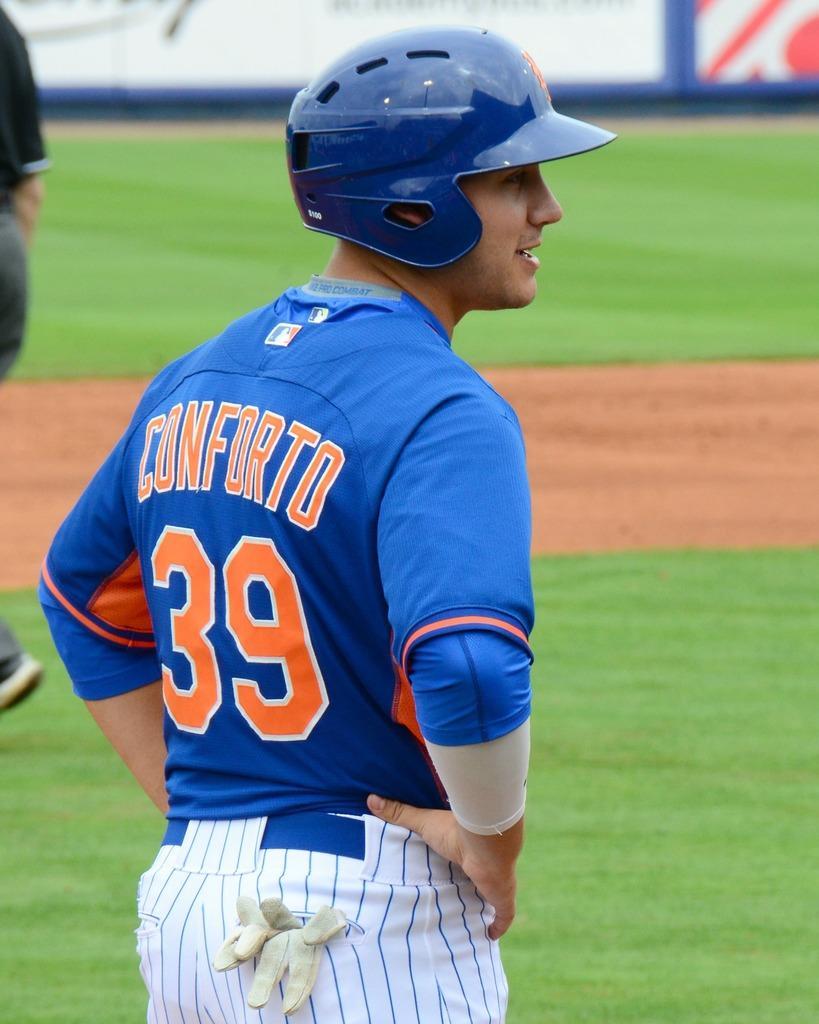How would you summarize this image in a sentence or two? In this picture there is a man wearing blue color t- shirt with white jeans and blue helmet, standing in the stadium ground and looking on the right side. Behind there is a white banner poster. 